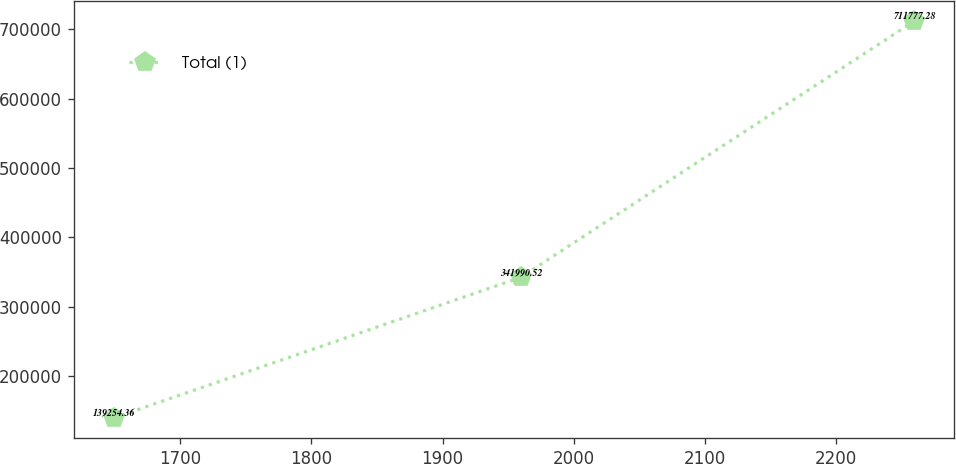Convert chart. <chart><loc_0><loc_0><loc_500><loc_500><line_chart><ecel><fcel>Total (1)<nl><fcel>1649.31<fcel>139254<nl><fcel>1959.41<fcel>341991<nl><fcel>2259.4<fcel>711777<nl></chart> 